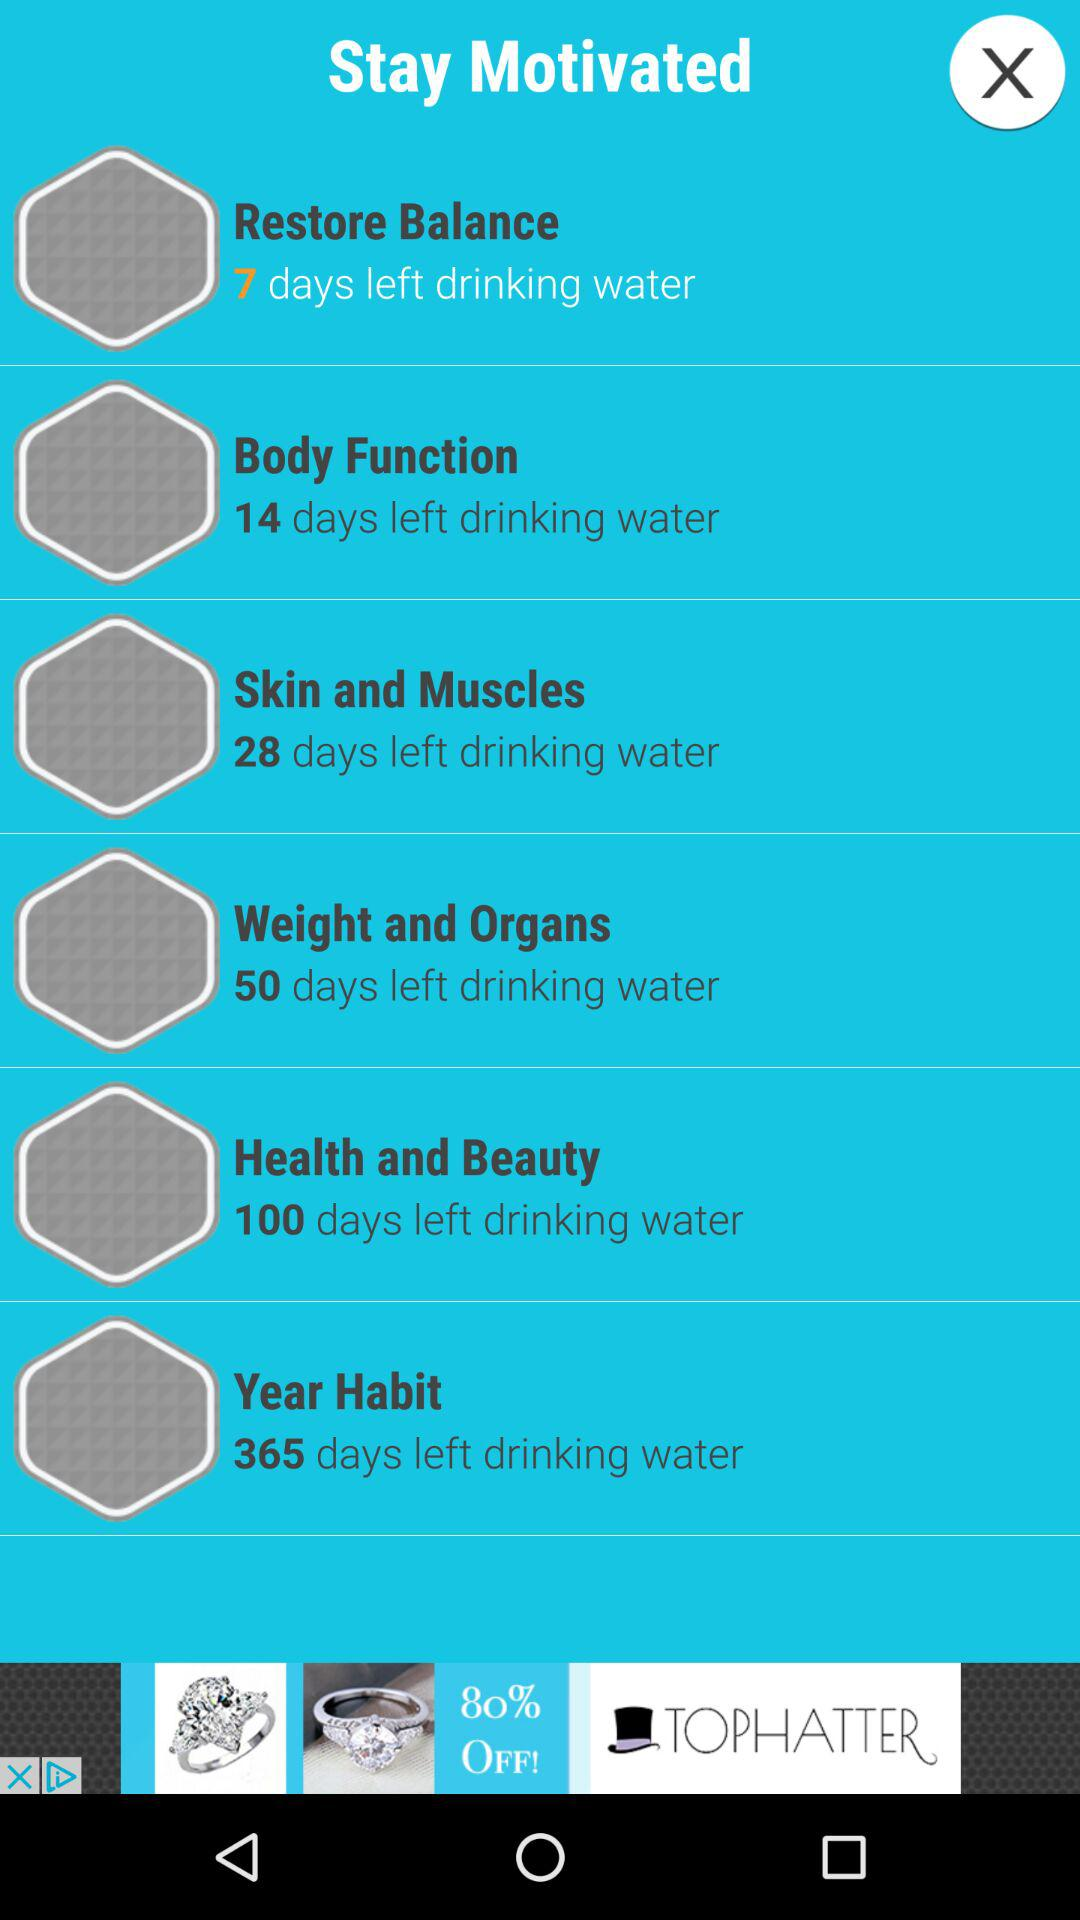Which function is displayed for "14 days left drinking water"? The displayed function is "Body Function". 